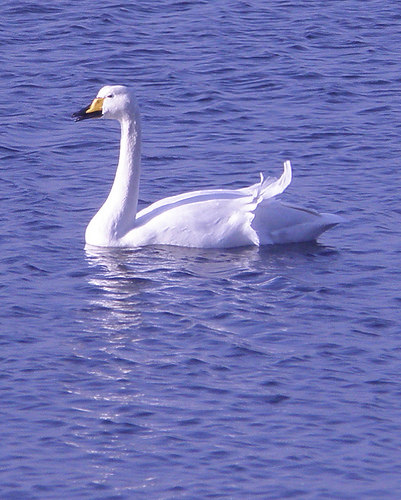<image>
Is the duck in the water? Yes. The duck is contained within or inside the water, showing a containment relationship. Where is the water in relation to the swan? Is it in front of the swan? No. The water is not in front of the swan. The spatial positioning shows a different relationship between these objects. Is there a duck above the water? No. The duck is not positioned above the water. The vertical arrangement shows a different relationship. 